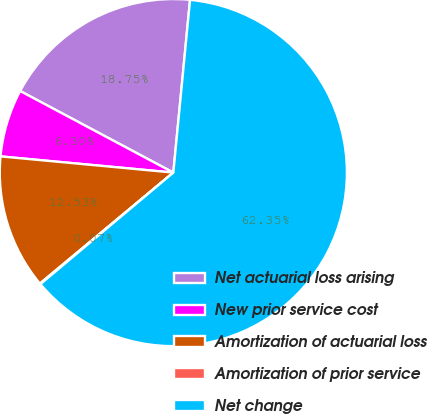Convert chart. <chart><loc_0><loc_0><loc_500><loc_500><pie_chart><fcel>Net actuarial loss arising<fcel>New prior service cost<fcel>Amortization of actuarial loss<fcel>Amortization of prior service<fcel>Net change<nl><fcel>18.75%<fcel>6.3%<fcel>12.53%<fcel>0.07%<fcel>62.36%<nl></chart> 